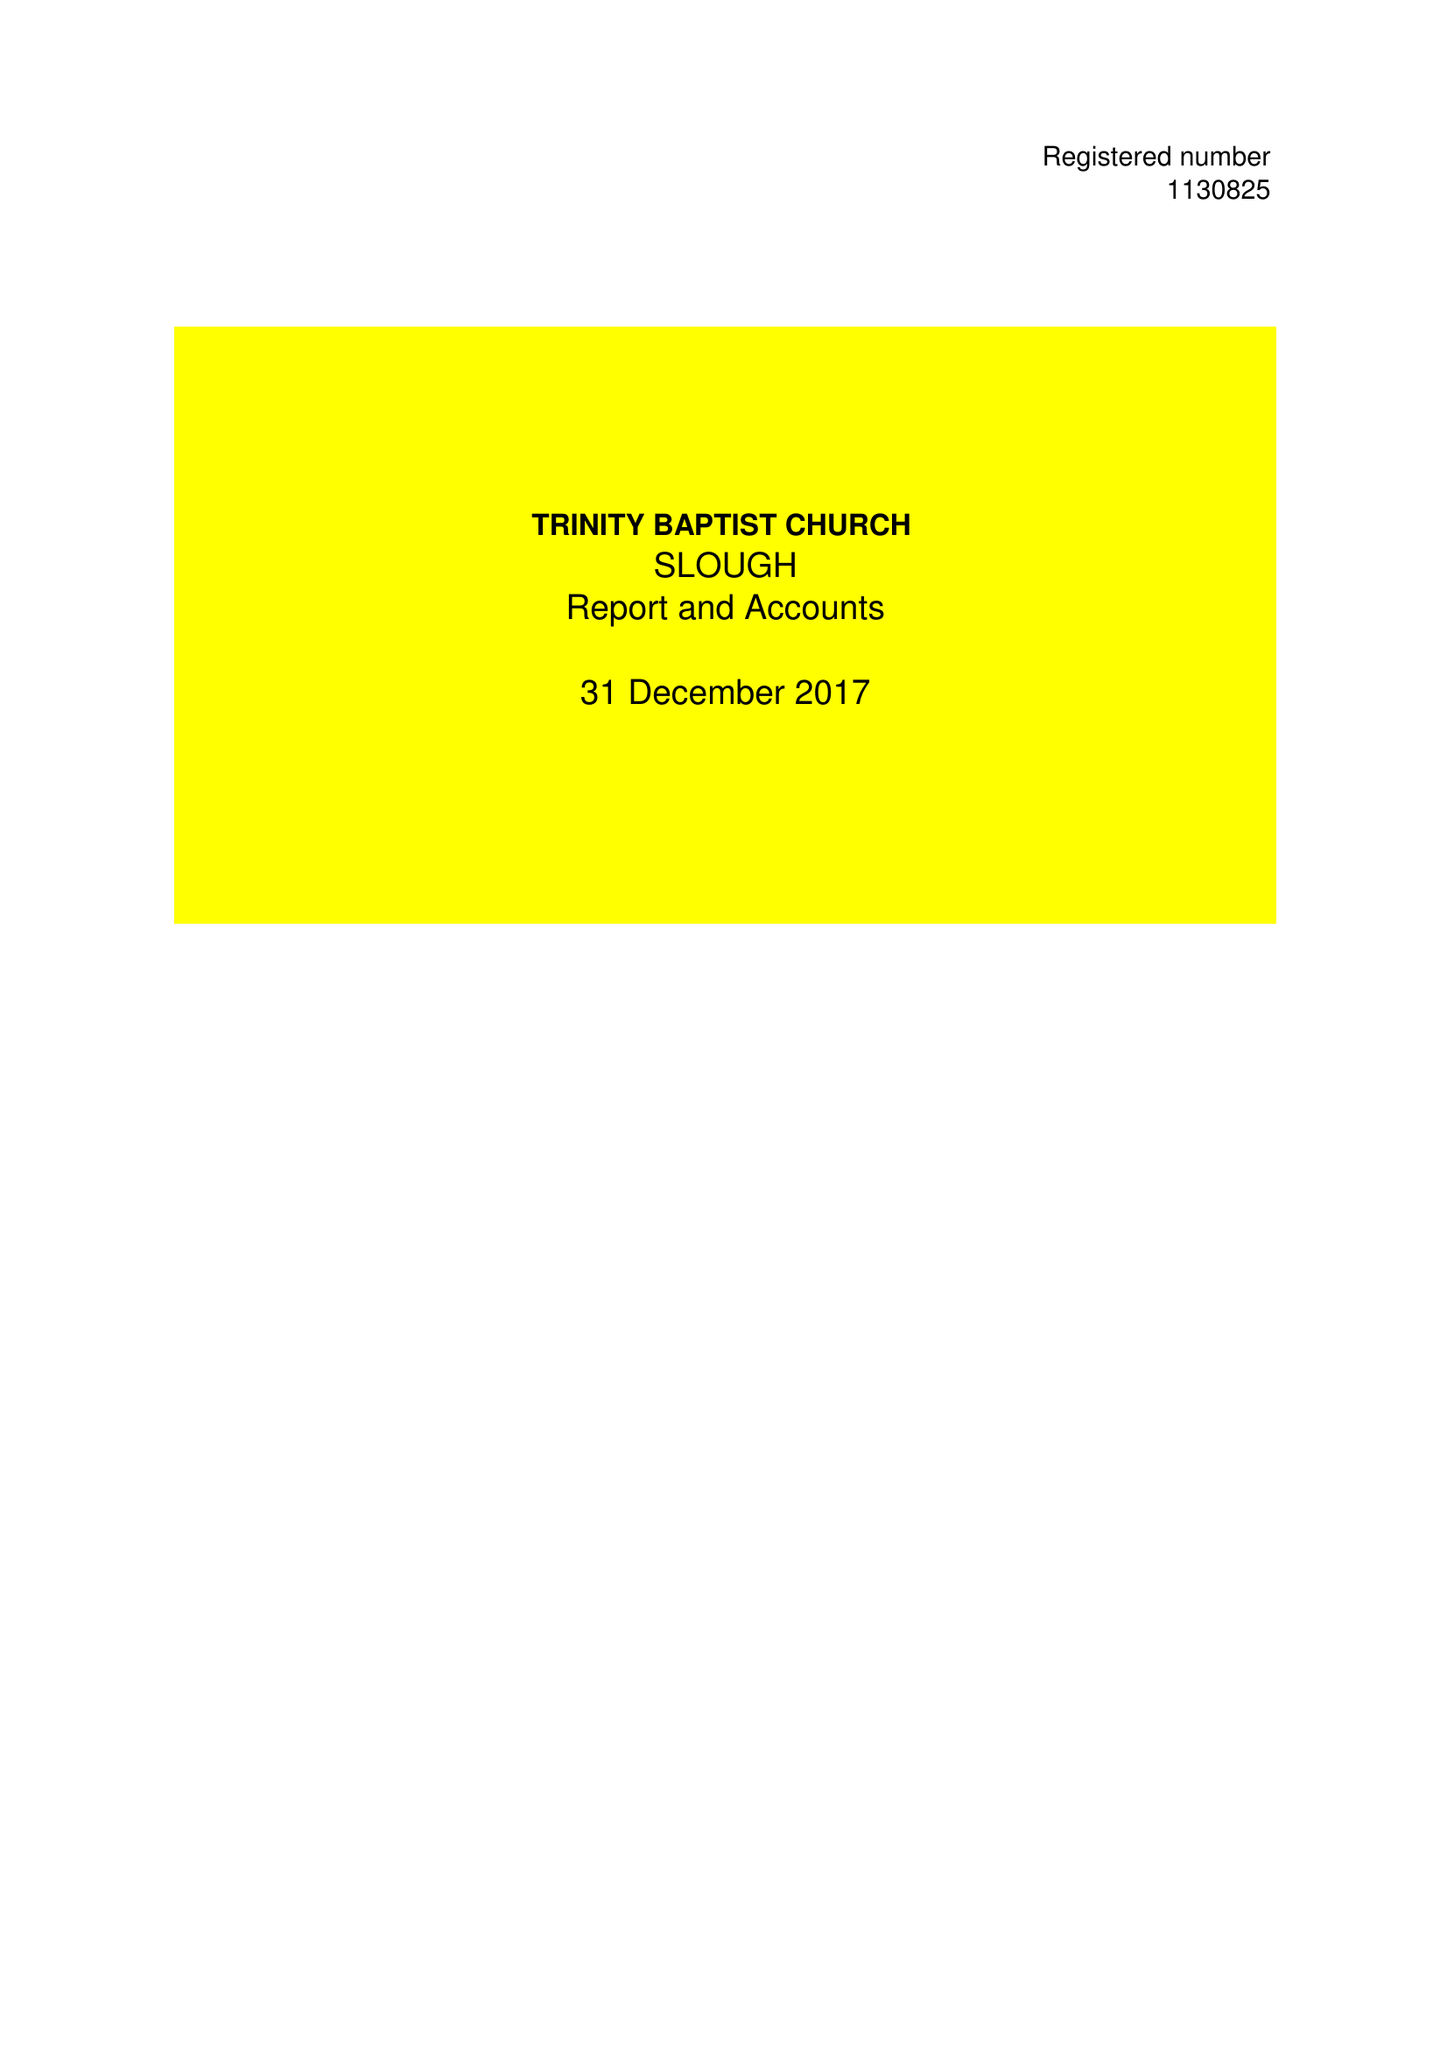What is the value for the report_date?
Answer the question using a single word or phrase. 2017-12-31 